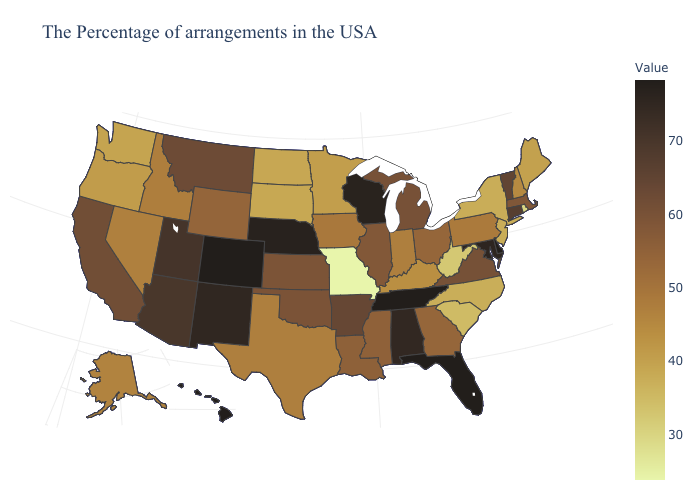Does the map have missing data?
Quick response, please. No. Does West Virginia have the lowest value in the South?
Write a very short answer. Yes. Among the states that border New Hampshire , which have the highest value?
Give a very brief answer. Vermont. 